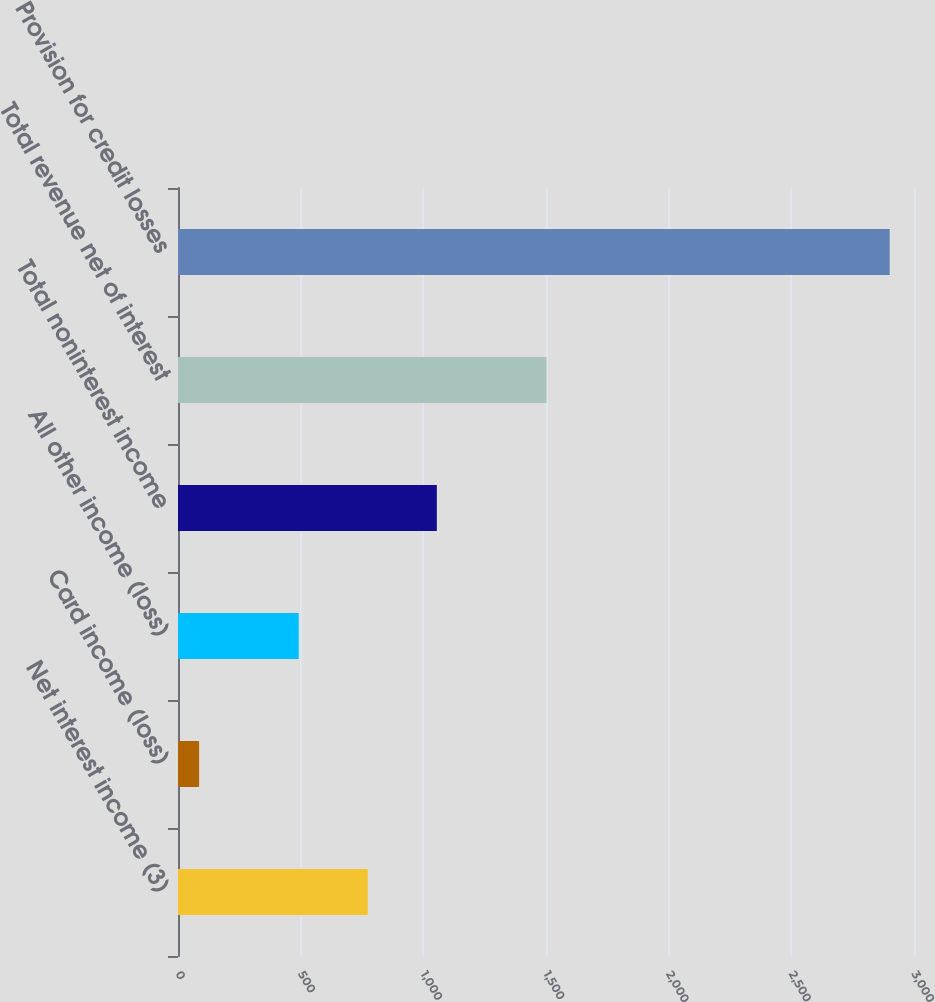Convert chart. <chart><loc_0><loc_0><loc_500><loc_500><bar_chart><fcel>Net interest income (3)<fcel>Card income (loss)<fcel>All other income (loss)<fcel>Total noninterest income<fcel>Total revenue net of interest<fcel>Provision for credit losses<nl><fcel>773.5<fcel>86<fcel>492<fcel>1055<fcel>1502<fcel>2901<nl></chart> 